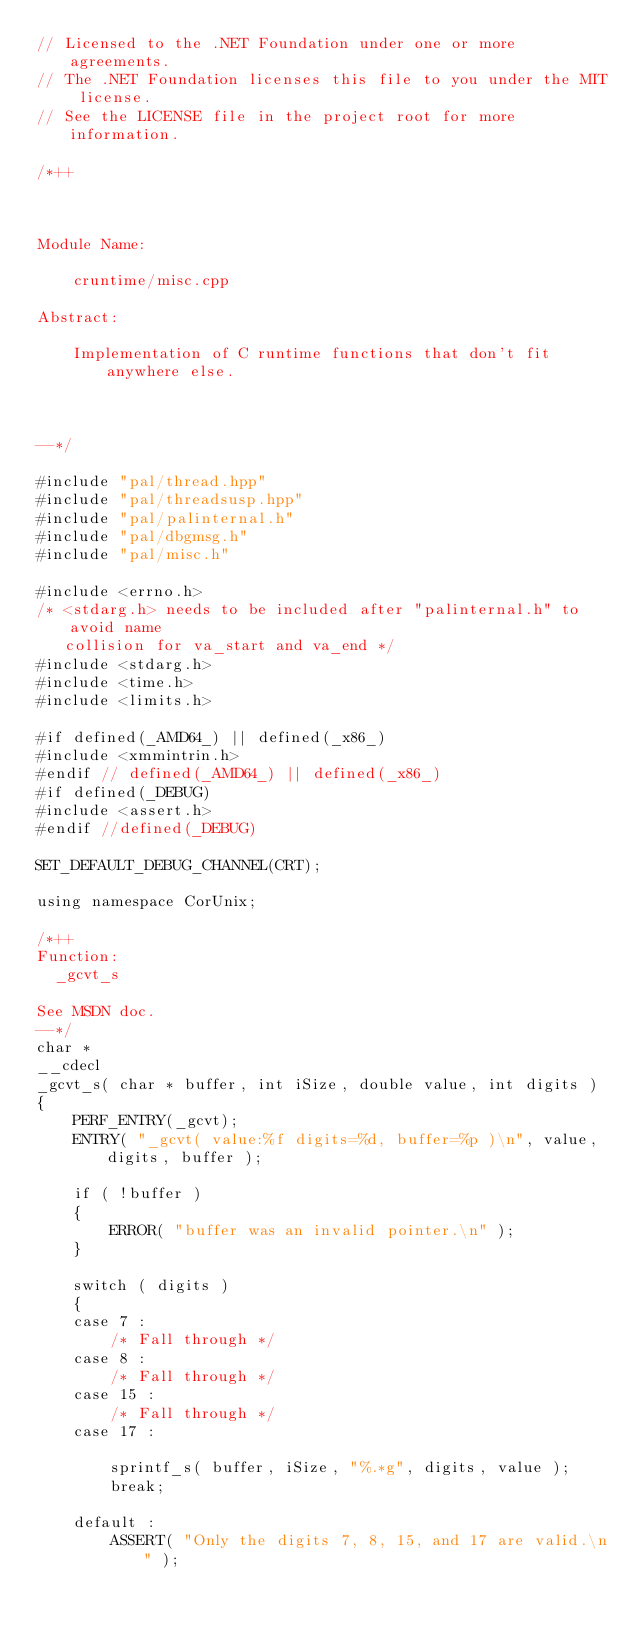Convert code to text. <code><loc_0><loc_0><loc_500><loc_500><_C++_>// Licensed to the .NET Foundation under one or more agreements.
// The .NET Foundation licenses this file to you under the MIT license.
// See the LICENSE file in the project root for more information.

/*++



Module Name:

    cruntime/misc.cpp

Abstract:

    Implementation of C runtime functions that don't fit anywhere else.



--*/

#include "pal/thread.hpp"
#include "pal/threadsusp.hpp"
#include "pal/palinternal.h"
#include "pal/dbgmsg.h"
#include "pal/misc.h"

#include <errno.h>
/* <stdarg.h> needs to be included after "palinternal.h" to avoid name
   collision for va_start and va_end */
#include <stdarg.h>
#include <time.h>
#include <limits.h>

#if defined(_AMD64_) || defined(_x86_)
#include <xmmintrin.h>
#endif // defined(_AMD64_) || defined(_x86_)
#if defined(_DEBUG)
#include <assert.h>
#endif //defined(_DEBUG)

SET_DEFAULT_DEBUG_CHANNEL(CRT);

using namespace CorUnix;

/*++
Function:
  _gcvt_s

See MSDN doc.
--*/
char * 
__cdecl 
_gcvt_s( char * buffer, int iSize, double value, int digits )
{
    PERF_ENTRY(_gcvt);
    ENTRY( "_gcvt( value:%f digits=%d, buffer=%p )\n", value, digits, buffer );    

    if ( !buffer )
    {
        ERROR( "buffer was an invalid pointer.\n" );
    }

    switch ( digits )
    {
    case 7 :
        /* Fall through */
    case 8 :
        /* Fall through */
    case 15 :
        /* Fall through */
    case 17 :
        
        sprintf_s( buffer, iSize, "%.*g", digits, value );
        break;
    
    default :
        ASSERT( "Only the digits 7, 8, 15, and 17 are valid.\n" );</code> 